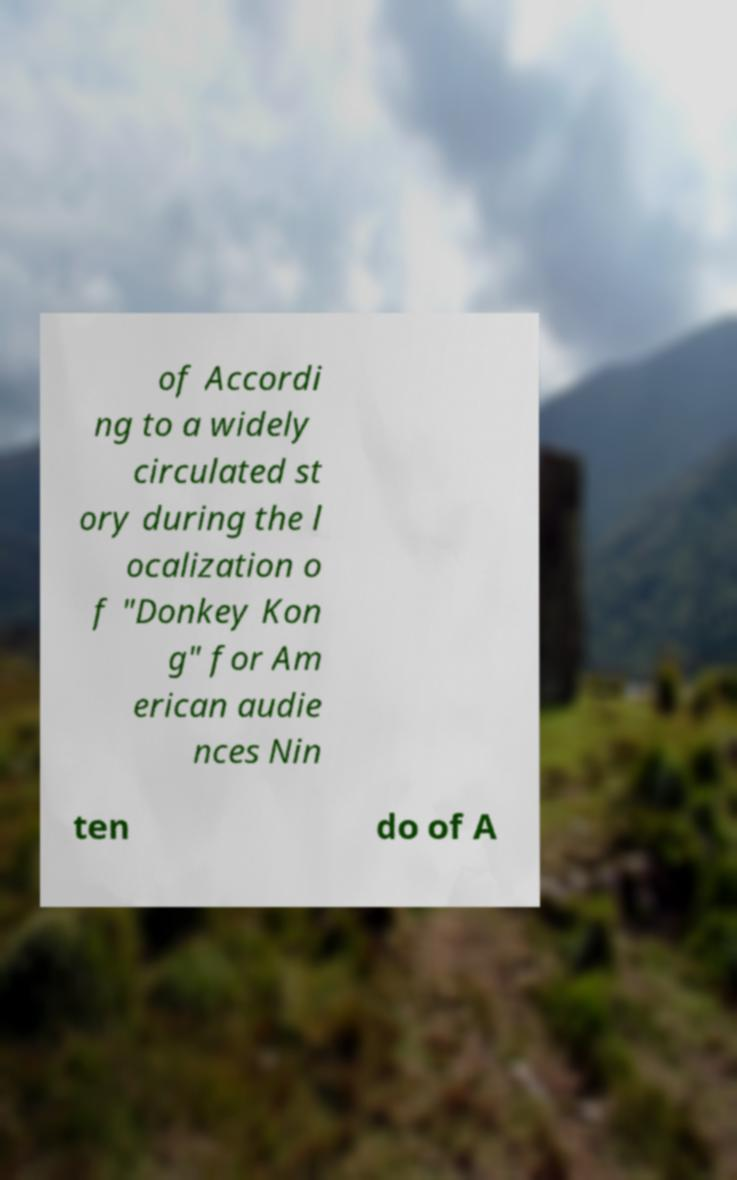There's text embedded in this image that I need extracted. Can you transcribe it verbatim? of Accordi ng to a widely circulated st ory during the l ocalization o f "Donkey Kon g" for Am erican audie nces Nin ten do of A 